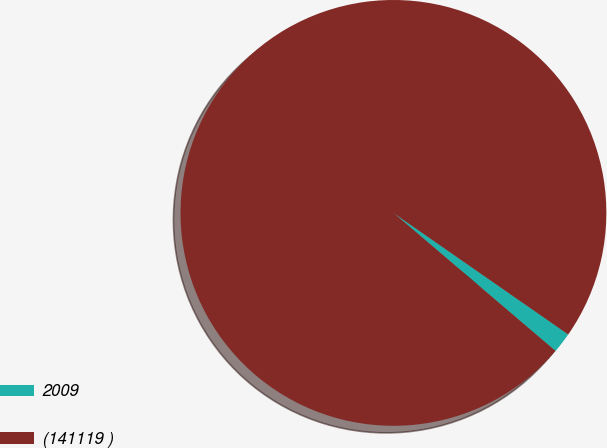Convert chart to OTSL. <chart><loc_0><loc_0><loc_500><loc_500><pie_chart><fcel>2009<fcel>(141119 )<nl><fcel>1.56%<fcel>98.44%<nl></chart> 